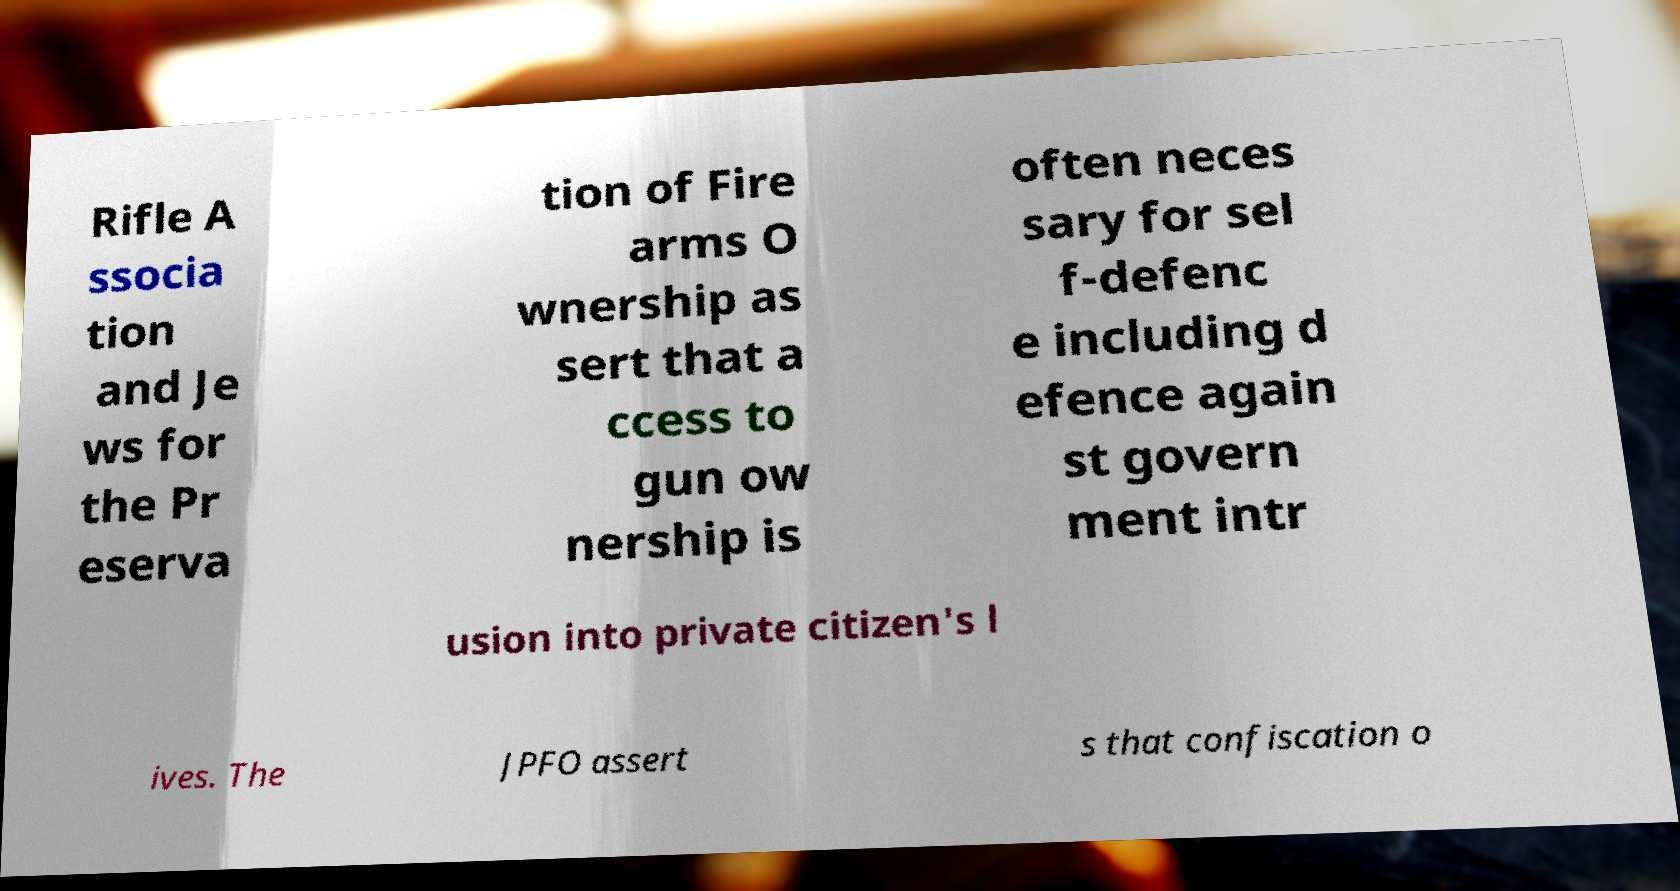Please identify and transcribe the text found in this image. Rifle A ssocia tion and Je ws for the Pr eserva tion of Fire arms O wnership as sert that a ccess to gun ow nership is often neces sary for sel f-defenc e including d efence again st govern ment intr usion into private citizen's l ives. The JPFO assert s that confiscation o 